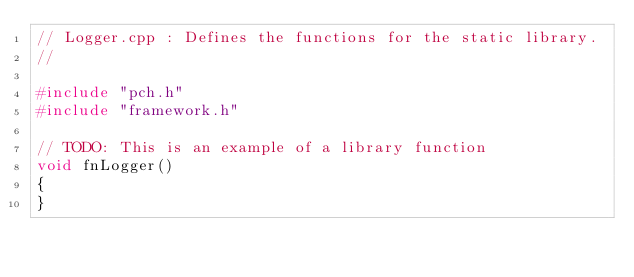<code> <loc_0><loc_0><loc_500><loc_500><_C++_>// Logger.cpp : Defines the functions for the static library.
//

#include "pch.h"
#include "framework.h"

// TODO: This is an example of a library function
void fnLogger()
{
}
</code> 